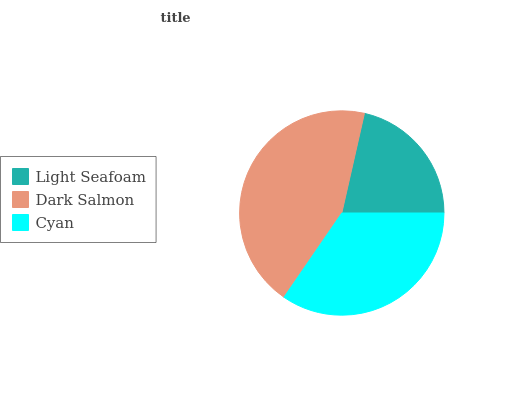Is Light Seafoam the minimum?
Answer yes or no. Yes. Is Dark Salmon the maximum?
Answer yes or no. Yes. Is Cyan the minimum?
Answer yes or no. No. Is Cyan the maximum?
Answer yes or no. No. Is Dark Salmon greater than Cyan?
Answer yes or no. Yes. Is Cyan less than Dark Salmon?
Answer yes or no. Yes. Is Cyan greater than Dark Salmon?
Answer yes or no. No. Is Dark Salmon less than Cyan?
Answer yes or no. No. Is Cyan the high median?
Answer yes or no. Yes. Is Cyan the low median?
Answer yes or no. Yes. Is Dark Salmon the high median?
Answer yes or no. No. Is Dark Salmon the low median?
Answer yes or no. No. 